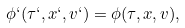Convert formula to latex. <formula><loc_0><loc_0><loc_500><loc_500>\phi ` ( \tau ` , x ` , v ` ) = \phi ( \tau , x , v ) ,</formula> 